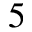Convert formula to latex. <formula><loc_0><loc_0><loc_500><loc_500>^ { 5 }</formula> 